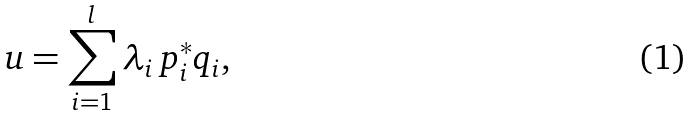<formula> <loc_0><loc_0><loc_500><loc_500>u = \sum _ { i = 1 } ^ { l } \lambda _ { i } \, p _ { i } ^ { * } q _ { i } ,</formula> 